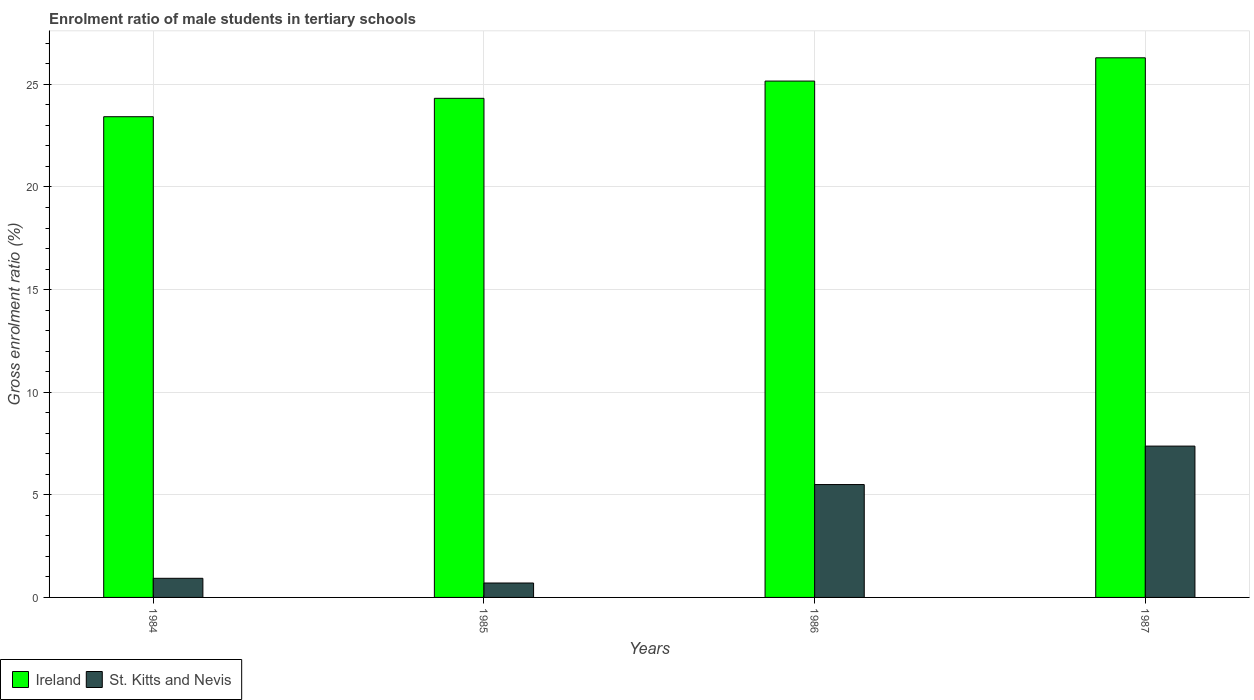How many different coloured bars are there?
Offer a very short reply. 2. How many groups of bars are there?
Provide a short and direct response. 4. Are the number of bars per tick equal to the number of legend labels?
Your response must be concise. Yes. How many bars are there on the 3rd tick from the right?
Ensure brevity in your answer.  2. What is the label of the 1st group of bars from the left?
Make the answer very short. 1984. What is the enrolment ratio of male students in tertiary schools in Ireland in 1984?
Provide a short and direct response. 23.43. Across all years, what is the maximum enrolment ratio of male students in tertiary schools in St. Kitts and Nevis?
Your response must be concise. 7.37. Across all years, what is the minimum enrolment ratio of male students in tertiary schools in St. Kitts and Nevis?
Provide a short and direct response. 0.7. What is the total enrolment ratio of male students in tertiary schools in Ireland in the graph?
Keep it short and to the point. 99.2. What is the difference between the enrolment ratio of male students in tertiary schools in St. Kitts and Nevis in 1985 and that in 1986?
Offer a terse response. -4.8. What is the difference between the enrolment ratio of male students in tertiary schools in St. Kitts and Nevis in 1987 and the enrolment ratio of male students in tertiary schools in Ireland in 1985?
Your answer should be very brief. -16.95. What is the average enrolment ratio of male students in tertiary schools in Ireland per year?
Ensure brevity in your answer.  24.8. In the year 1986, what is the difference between the enrolment ratio of male students in tertiary schools in Ireland and enrolment ratio of male students in tertiary schools in St. Kitts and Nevis?
Offer a very short reply. 19.66. What is the ratio of the enrolment ratio of male students in tertiary schools in Ireland in 1984 to that in 1985?
Your response must be concise. 0.96. Is the enrolment ratio of male students in tertiary schools in St. Kitts and Nevis in 1984 less than that in 1985?
Your answer should be compact. No. Is the difference between the enrolment ratio of male students in tertiary schools in Ireland in 1984 and 1986 greater than the difference between the enrolment ratio of male students in tertiary schools in St. Kitts and Nevis in 1984 and 1986?
Your answer should be very brief. Yes. What is the difference between the highest and the second highest enrolment ratio of male students in tertiary schools in St. Kitts and Nevis?
Your response must be concise. 1.87. What is the difference between the highest and the lowest enrolment ratio of male students in tertiary schools in St. Kitts and Nevis?
Offer a terse response. 6.67. What does the 1st bar from the left in 1986 represents?
Offer a very short reply. Ireland. What does the 2nd bar from the right in 1984 represents?
Make the answer very short. Ireland. How many bars are there?
Provide a succinct answer. 8. What is the difference between two consecutive major ticks on the Y-axis?
Give a very brief answer. 5. Are the values on the major ticks of Y-axis written in scientific E-notation?
Make the answer very short. No. What is the title of the graph?
Give a very brief answer. Enrolment ratio of male students in tertiary schools. What is the Gross enrolment ratio (%) in Ireland in 1984?
Offer a terse response. 23.43. What is the Gross enrolment ratio (%) of St. Kitts and Nevis in 1984?
Offer a very short reply. 0.93. What is the Gross enrolment ratio (%) in Ireland in 1985?
Your answer should be very brief. 24.32. What is the Gross enrolment ratio (%) of St. Kitts and Nevis in 1985?
Provide a short and direct response. 0.7. What is the Gross enrolment ratio (%) of Ireland in 1986?
Your response must be concise. 25.16. What is the Gross enrolment ratio (%) in St. Kitts and Nevis in 1986?
Give a very brief answer. 5.5. What is the Gross enrolment ratio (%) in Ireland in 1987?
Ensure brevity in your answer.  26.3. What is the Gross enrolment ratio (%) in St. Kitts and Nevis in 1987?
Make the answer very short. 7.37. Across all years, what is the maximum Gross enrolment ratio (%) in Ireland?
Offer a terse response. 26.3. Across all years, what is the maximum Gross enrolment ratio (%) of St. Kitts and Nevis?
Offer a terse response. 7.37. Across all years, what is the minimum Gross enrolment ratio (%) of Ireland?
Give a very brief answer. 23.43. Across all years, what is the minimum Gross enrolment ratio (%) in St. Kitts and Nevis?
Your answer should be compact. 0.7. What is the total Gross enrolment ratio (%) in Ireland in the graph?
Offer a terse response. 99.2. What is the total Gross enrolment ratio (%) in St. Kitts and Nevis in the graph?
Your response must be concise. 14.51. What is the difference between the Gross enrolment ratio (%) of Ireland in 1984 and that in 1985?
Keep it short and to the point. -0.9. What is the difference between the Gross enrolment ratio (%) in St. Kitts and Nevis in 1984 and that in 1985?
Provide a short and direct response. 0.23. What is the difference between the Gross enrolment ratio (%) in Ireland in 1984 and that in 1986?
Provide a succinct answer. -1.74. What is the difference between the Gross enrolment ratio (%) of St. Kitts and Nevis in 1984 and that in 1986?
Ensure brevity in your answer.  -4.57. What is the difference between the Gross enrolment ratio (%) of Ireland in 1984 and that in 1987?
Your response must be concise. -2.87. What is the difference between the Gross enrolment ratio (%) of St. Kitts and Nevis in 1984 and that in 1987?
Ensure brevity in your answer.  -6.44. What is the difference between the Gross enrolment ratio (%) of Ireland in 1985 and that in 1986?
Your answer should be very brief. -0.84. What is the difference between the Gross enrolment ratio (%) of St. Kitts and Nevis in 1985 and that in 1986?
Your response must be concise. -4.8. What is the difference between the Gross enrolment ratio (%) of Ireland in 1985 and that in 1987?
Keep it short and to the point. -1.97. What is the difference between the Gross enrolment ratio (%) in St. Kitts and Nevis in 1985 and that in 1987?
Make the answer very short. -6.67. What is the difference between the Gross enrolment ratio (%) of Ireland in 1986 and that in 1987?
Offer a terse response. -1.13. What is the difference between the Gross enrolment ratio (%) of St. Kitts and Nevis in 1986 and that in 1987?
Your answer should be compact. -1.87. What is the difference between the Gross enrolment ratio (%) of Ireland in 1984 and the Gross enrolment ratio (%) of St. Kitts and Nevis in 1985?
Offer a very short reply. 22.72. What is the difference between the Gross enrolment ratio (%) of Ireland in 1984 and the Gross enrolment ratio (%) of St. Kitts and Nevis in 1986?
Give a very brief answer. 17.92. What is the difference between the Gross enrolment ratio (%) in Ireland in 1984 and the Gross enrolment ratio (%) in St. Kitts and Nevis in 1987?
Your response must be concise. 16.05. What is the difference between the Gross enrolment ratio (%) in Ireland in 1985 and the Gross enrolment ratio (%) in St. Kitts and Nevis in 1986?
Give a very brief answer. 18.82. What is the difference between the Gross enrolment ratio (%) of Ireland in 1985 and the Gross enrolment ratio (%) of St. Kitts and Nevis in 1987?
Provide a short and direct response. 16.95. What is the difference between the Gross enrolment ratio (%) in Ireland in 1986 and the Gross enrolment ratio (%) in St. Kitts and Nevis in 1987?
Provide a short and direct response. 17.79. What is the average Gross enrolment ratio (%) of Ireland per year?
Provide a succinct answer. 24.8. What is the average Gross enrolment ratio (%) in St. Kitts and Nevis per year?
Keep it short and to the point. 3.63. In the year 1984, what is the difference between the Gross enrolment ratio (%) in Ireland and Gross enrolment ratio (%) in St. Kitts and Nevis?
Your answer should be very brief. 22.49. In the year 1985, what is the difference between the Gross enrolment ratio (%) in Ireland and Gross enrolment ratio (%) in St. Kitts and Nevis?
Make the answer very short. 23.62. In the year 1986, what is the difference between the Gross enrolment ratio (%) of Ireland and Gross enrolment ratio (%) of St. Kitts and Nevis?
Your response must be concise. 19.66. In the year 1987, what is the difference between the Gross enrolment ratio (%) of Ireland and Gross enrolment ratio (%) of St. Kitts and Nevis?
Make the answer very short. 18.92. What is the ratio of the Gross enrolment ratio (%) in Ireland in 1984 to that in 1985?
Offer a terse response. 0.96. What is the ratio of the Gross enrolment ratio (%) of St. Kitts and Nevis in 1984 to that in 1985?
Ensure brevity in your answer.  1.33. What is the ratio of the Gross enrolment ratio (%) of Ireland in 1984 to that in 1986?
Give a very brief answer. 0.93. What is the ratio of the Gross enrolment ratio (%) in St. Kitts and Nevis in 1984 to that in 1986?
Ensure brevity in your answer.  0.17. What is the ratio of the Gross enrolment ratio (%) in Ireland in 1984 to that in 1987?
Give a very brief answer. 0.89. What is the ratio of the Gross enrolment ratio (%) in St. Kitts and Nevis in 1984 to that in 1987?
Make the answer very short. 0.13. What is the ratio of the Gross enrolment ratio (%) of Ireland in 1985 to that in 1986?
Offer a very short reply. 0.97. What is the ratio of the Gross enrolment ratio (%) in St. Kitts and Nevis in 1985 to that in 1986?
Ensure brevity in your answer.  0.13. What is the ratio of the Gross enrolment ratio (%) in Ireland in 1985 to that in 1987?
Your answer should be very brief. 0.92. What is the ratio of the Gross enrolment ratio (%) of St. Kitts and Nevis in 1985 to that in 1987?
Your response must be concise. 0.1. What is the ratio of the Gross enrolment ratio (%) of Ireland in 1986 to that in 1987?
Keep it short and to the point. 0.96. What is the ratio of the Gross enrolment ratio (%) of St. Kitts and Nevis in 1986 to that in 1987?
Provide a short and direct response. 0.75. What is the difference between the highest and the second highest Gross enrolment ratio (%) in Ireland?
Ensure brevity in your answer.  1.13. What is the difference between the highest and the second highest Gross enrolment ratio (%) in St. Kitts and Nevis?
Ensure brevity in your answer.  1.87. What is the difference between the highest and the lowest Gross enrolment ratio (%) of Ireland?
Your response must be concise. 2.87. What is the difference between the highest and the lowest Gross enrolment ratio (%) in St. Kitts and Nevis?
Offer a very short reply. 6.67. 